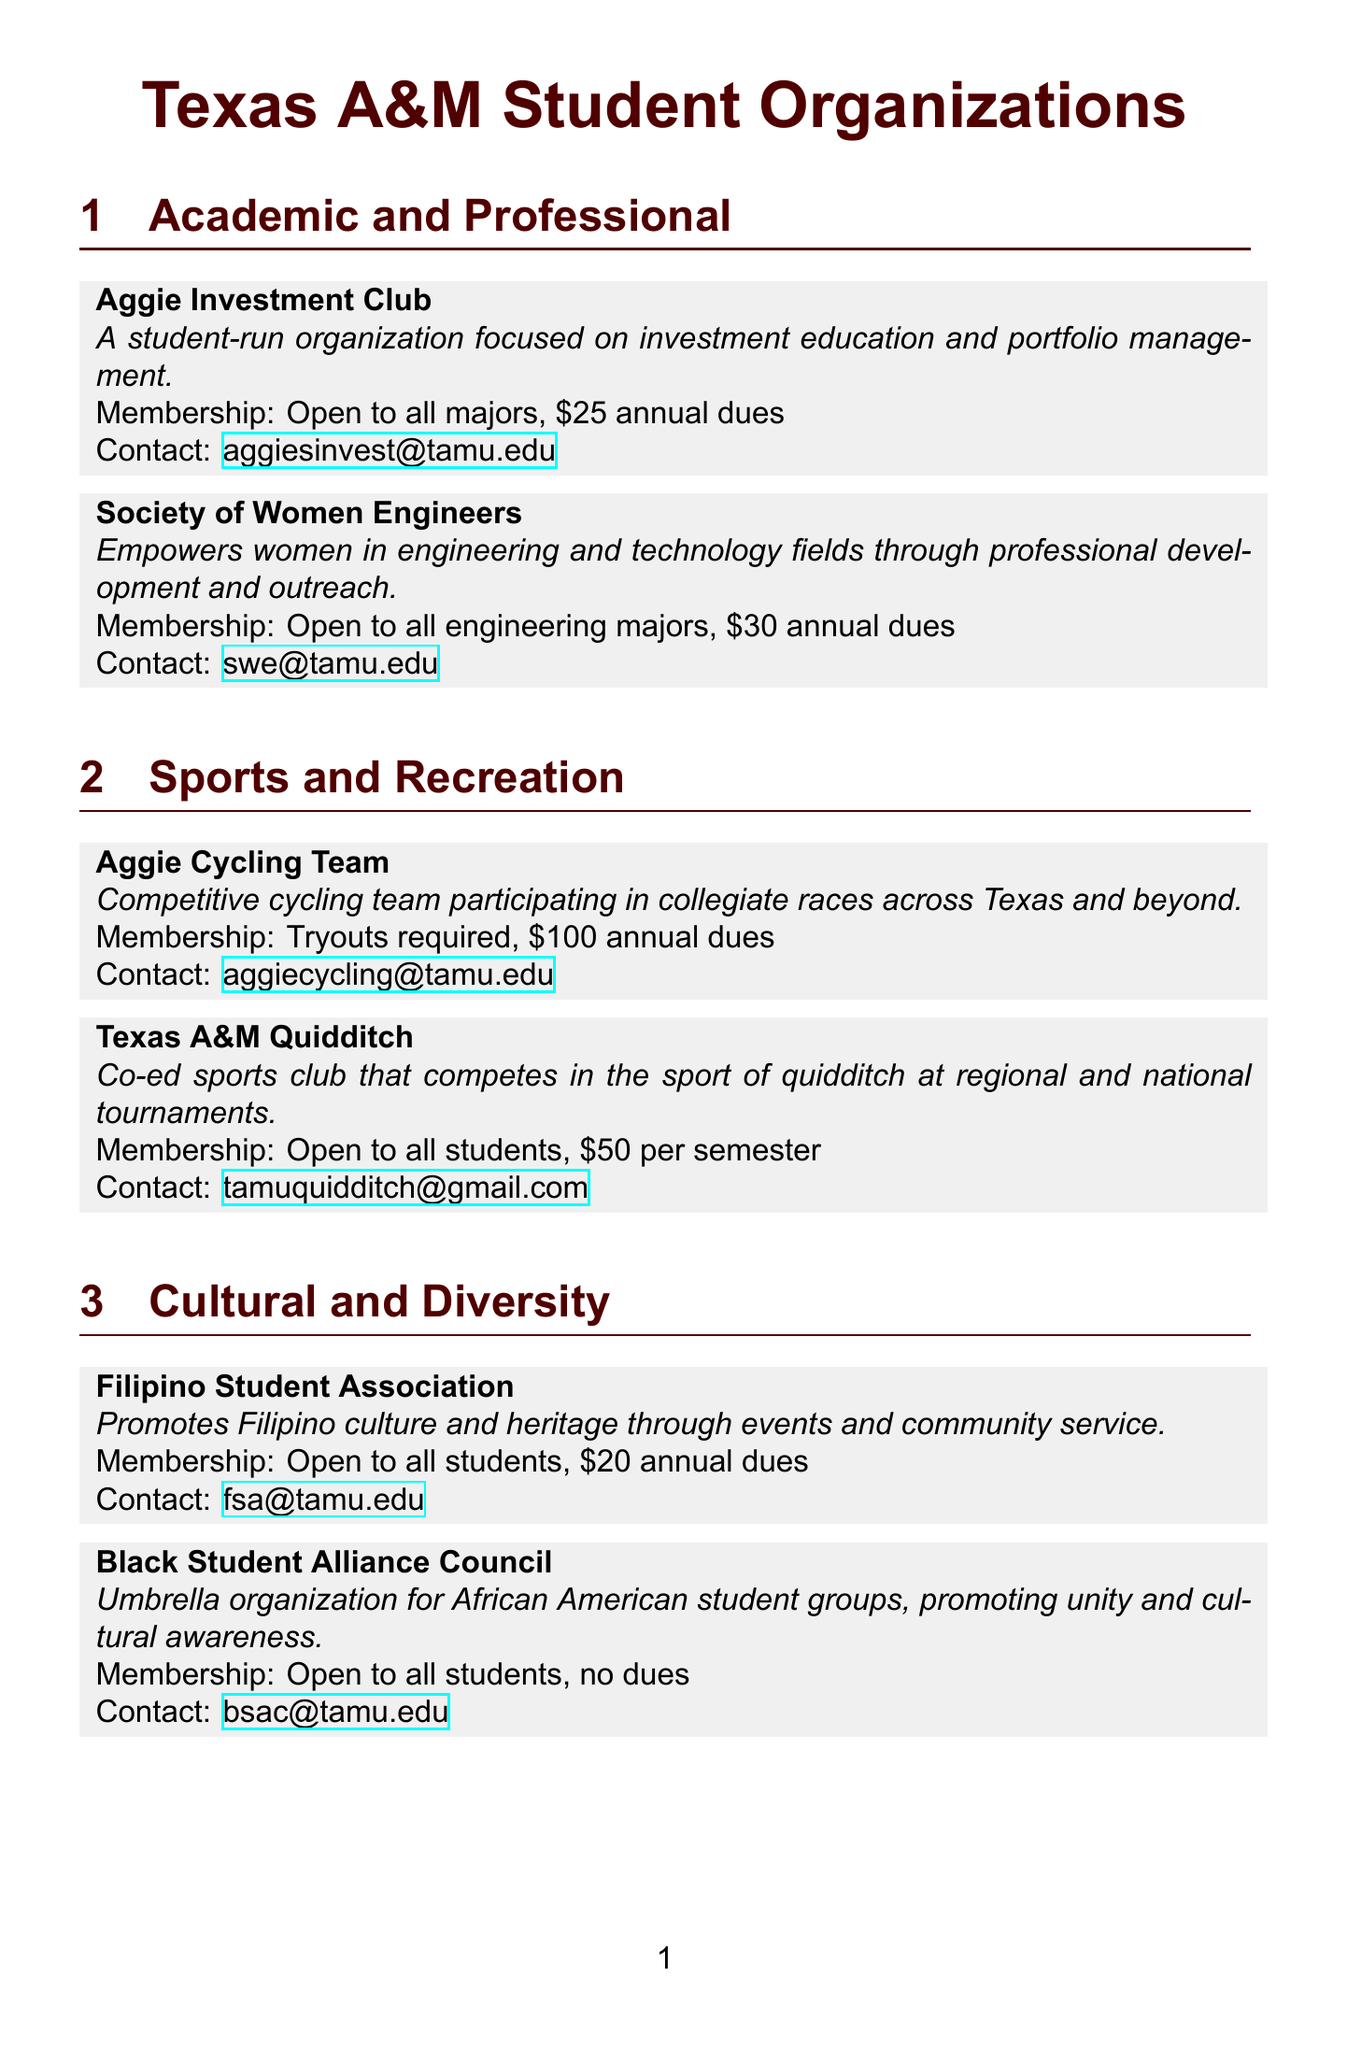What is the membership requirement for the Aggie Investment Club? The membership requirement for the Aggie Investment Club is stated as "Open to all majors, $25 annual dues."
Answer: Open to all majors, $25 annual dues What is the contact email for the Society of Women Engineers? The contact email for the Society of Women Engineers is provided in the document as "swe@tamu.edu."
Answer: swe@tamu.edu How much are the annual dues for the Filipino Student Association? The annual dues for the Filipino Student Association are specified as "$20 annual dues."
Answer: $20 annual dues Which organization requires tryouts for membership? The Aggie Cycling Team specifically states that "Tryouts required" in its membership requirements.
Answer: Aggie Cycling Team What is the main purpose of the Big Event? The Big Event is described as "Largest one-day, student-run service project in the nation, giving back to the local community."
Answer: Giving back to the local community How often is the MSC Open House held? The MSC Open House is stated to be "Held at the beginning of each fall and spring semester."
Answer: Beginning of each fall and spring semester What is the website for the Department of Student Activities? The website for the Department of Student Activities is provided as "https://studentactivities.tamu.edu/."
Answer: https://studentactivities.tamu.edu/ What type of organizations fall under the category of Cultural and Diversity? The organizations categorized as Cultural and Diversity include the Filipino Student Association and the Black Student Alliance Council, both promoting culture and diversity.
Answer: Filipino Student Association, Black Student Alliance Council Which category does the Aggie Players belong to? The Aggie Players are listed under the "Arts and Performance" category in the document.
Answer: Arts and Performance 